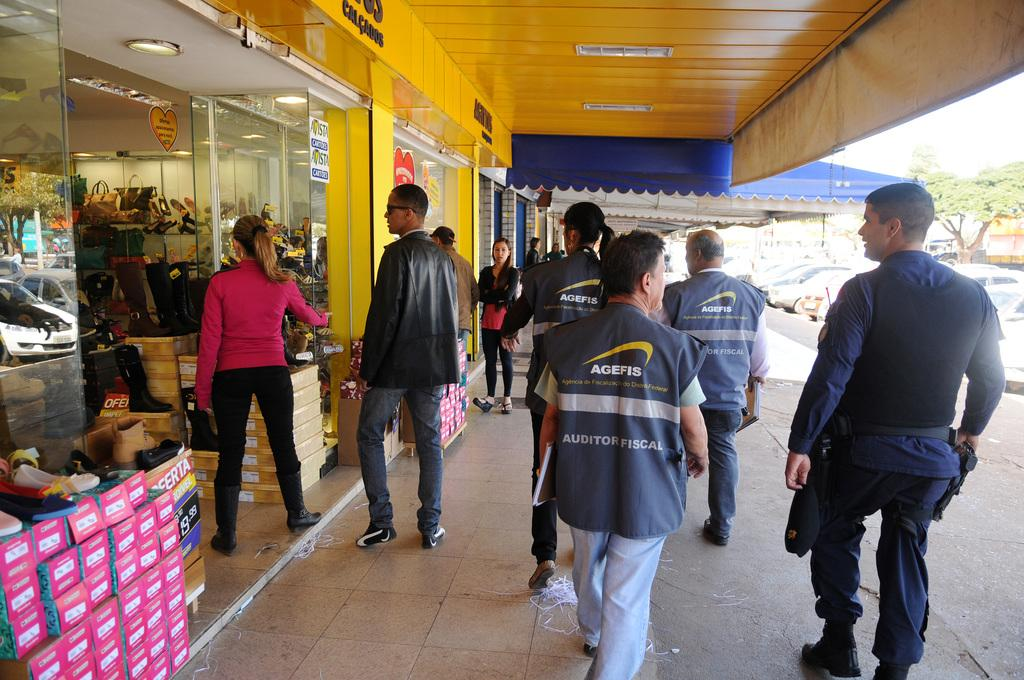What type of structures can be seen in the image? There are buildings in the image. What type of establishments can be found within these structures? There are stores in the image. What type of packaging is visible in the image? Cardboard cartons are visible in the image. What type of transportation is present on the road in the image? Motor vehicles are present on the road in the image. What type of natural elements can be seen in the image? Trees are present in the image. What part of the environment is visible in the image? The sky is visible in the image. What type of activity can be observed among the persons in the image? Persons are walking on the floor in the image. Where can the stamp be found in the image? There is no stamp present in the image. What type of furniture is used to store the milk in the image? There is no milk or shelf present in the image. 